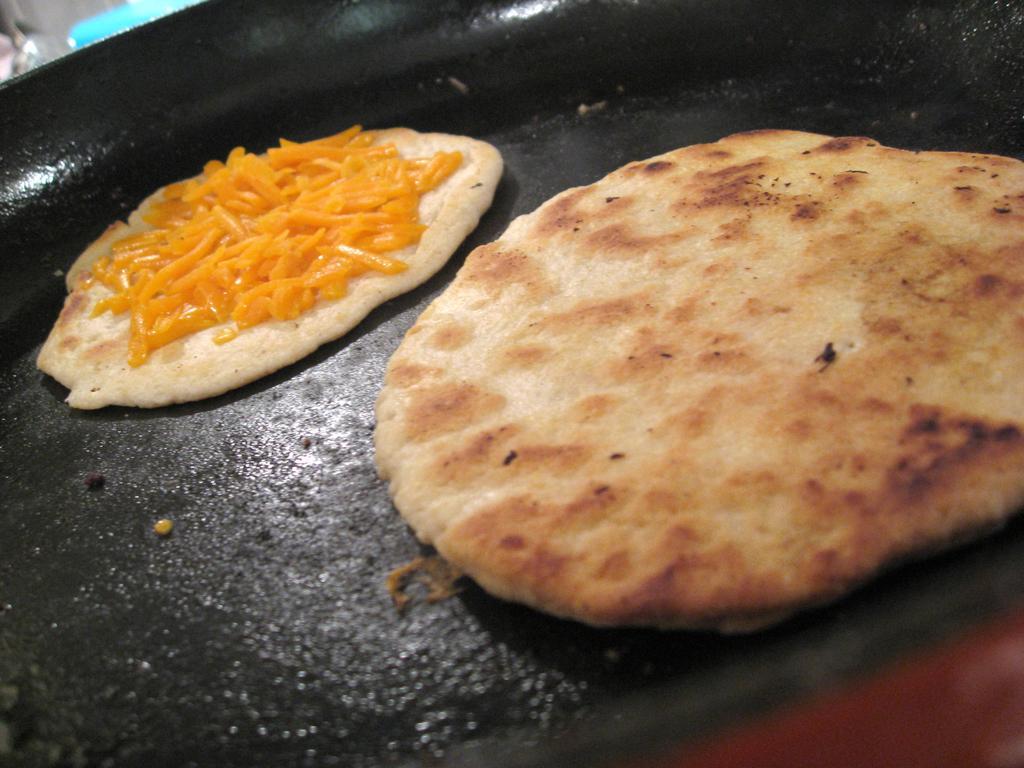How would you summarize this image in a sentence or two? In this picture, we can see a black color pan. On that pan, we can see some food items. 